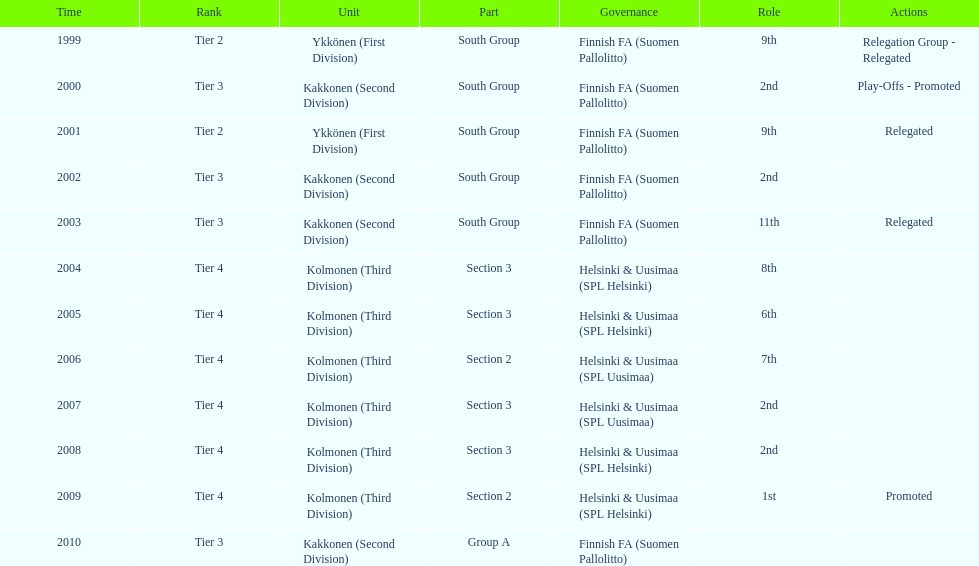What is the first tier listed? Tier 2. 